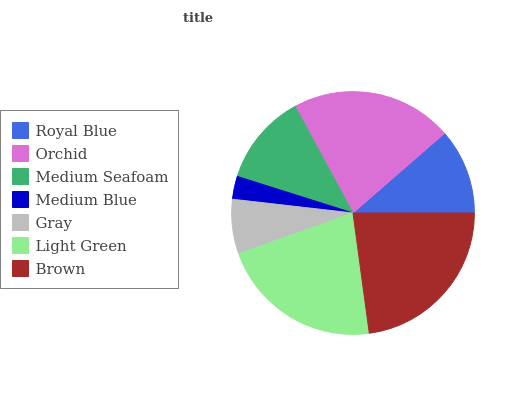Is Medium Blue the minimum?
Answer yes or no. Yes. Is Brown the maximum?
Answer yes or no. Yes. Is Orchid the minimum?
Answer yes or no. No. Is Orchid the maximum?
Answer yes or no. No. Is Orchid greater than Royal Blue?
Answer yes or no. Yes. Is Royal Blue less than Orchid?
Answer yes or no. Yes. Is Royal Blue greater than Orchid?
Answer yes or no. No. Is Orchid less than Royal Blue?
Answer yes or no. No. Is Medium Seafoam the high median?
Answer yes or no. Yes. Is Medium Seafoam the low median?
Answer yes or no. Yes. Is Orchid the high median?
Answer yes or no. No. Is Light Green the low median?
Answer yes or no. No. 